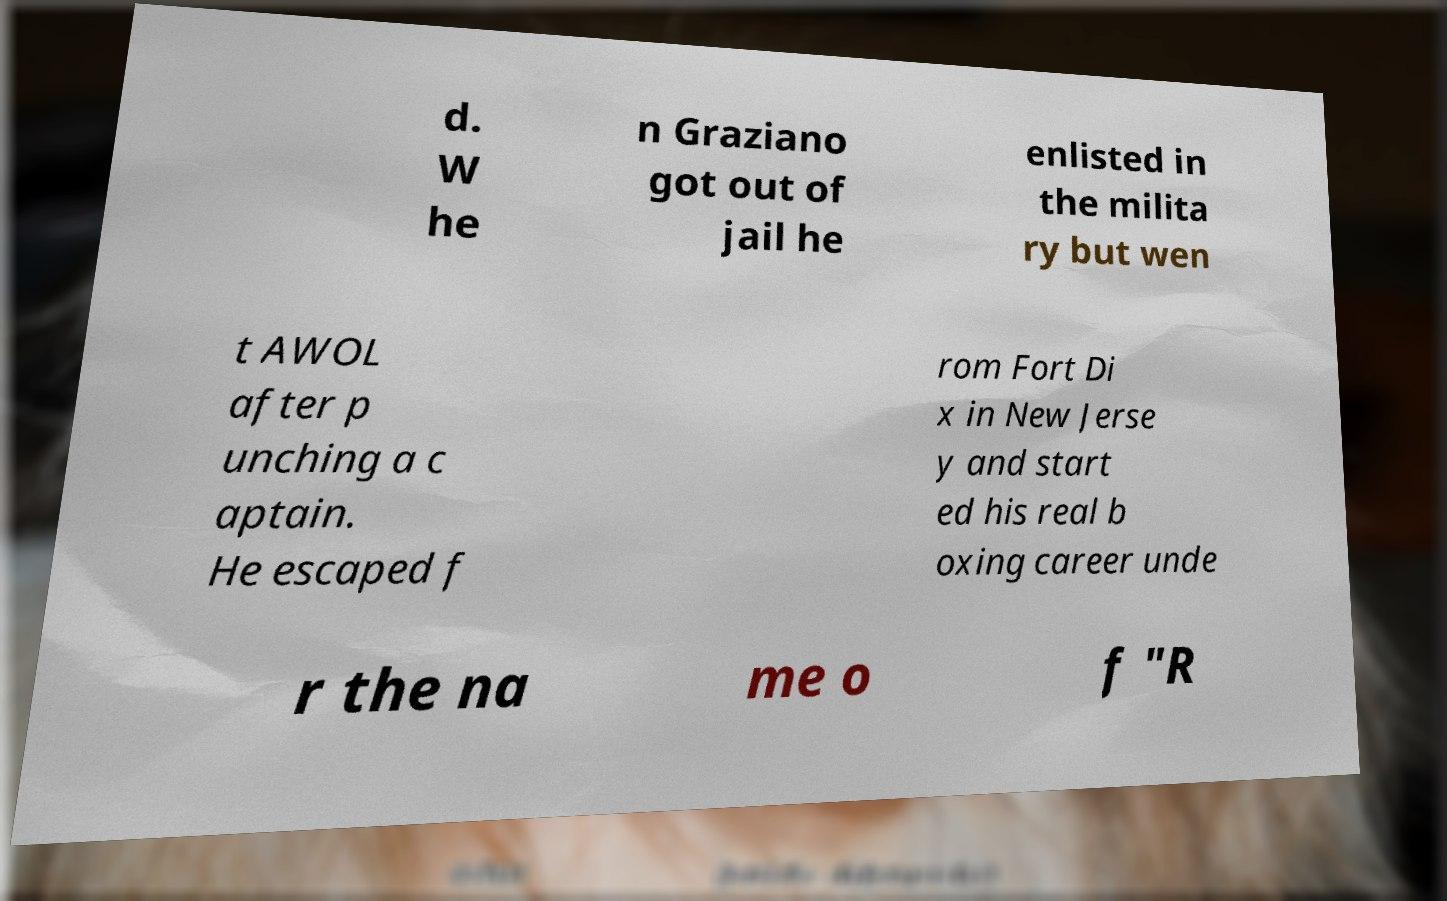For documentation purposes, I need the text within this image transcribed. Could you provide that? d. W he n Graziano got out of jail he enlisted in the milita ry but wen t AWOL after p unching a c aptain. He escaped f rom Fort Di x in New Jerse y and start ed his real b oxing career unde r the na me o f "R 